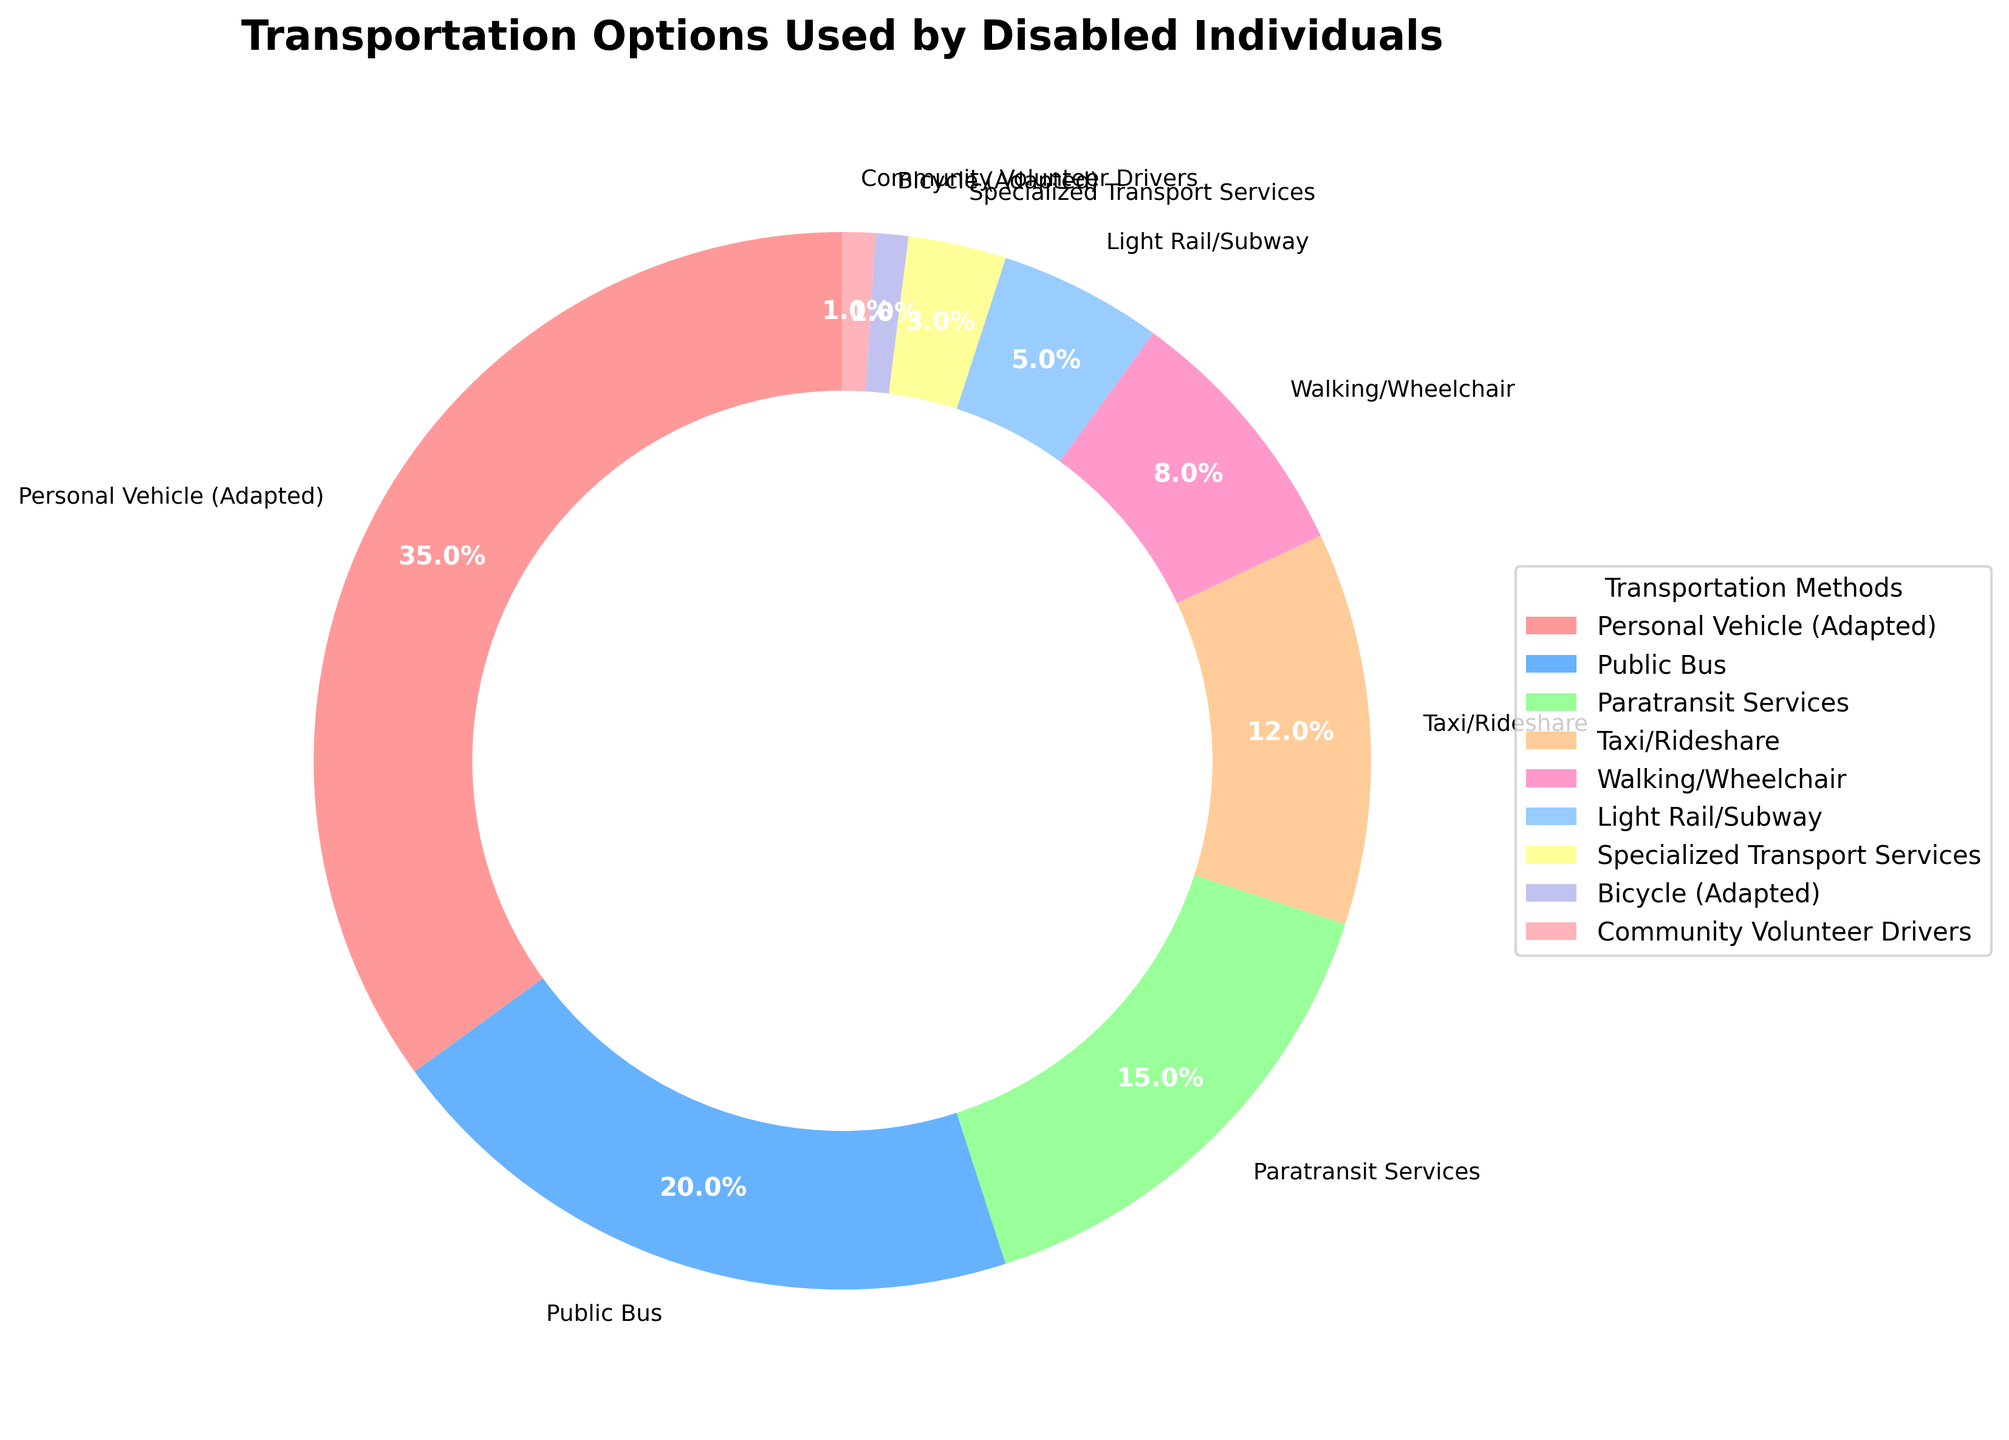Which transportation method is the most commonly used by disabled individuals? The pie chart shows that the largest segment corresponds to "Personal Vehicle (Adapted)" with a percentage of 35%.
Answer: Personal Vehicle (Adapted) Which transportation methods have a smaller percentage than taxi/rideshare? According to the pie chart, the methods with a smaller percentage than "Taxi/Rideshare" (12%) are "Walking/Wheelchair" (8%), "Light Rail/Subway" (5%), "Specialized Transport Services" (3%), "Bicycle (Adapted)" (1%), and "Community Volunteer Drivers" (1%).
Answer: Walking/Wheelchair, Light Rail/Subway, Specialized Transport Services, Bicycle (Adapted), Community Volunteer Drivers What is the combined percentage of Public Bus and Paratransit Services usage? The percentage usage for "Public Bus" is 20% and for "Paratransit Services" is 15%. Adding these together gives 20% + 15% = 35%.
Answer: 35% How does the usage of Paratransit Services compare to Specialized Transport Services? The pie chart indicates that "Paratransit Services" has a usage percentage of 15%, while "Specialized Transport Services" has a percentage of 3%. Comparatively, Paratransit Services are used much more frequently than Specialized Transport Services.
Answer: Paratransit Services is used more What color represents the segment for Community Volunteer Drivers in the pie chart? The segment for "Community Volunteer Drivers" is colored in a light blue hue, distinguished from other colors in the pie chart.
Answer: Light blue What is the difference in usage percentages between the most and least used transportation methods? The most used transportation method is "Personal Vehicle (Adapted)" with 35%, and the least used methods are "Bicycle (Adapted)" and "Community Volunteer Drivers," both with 1%. The difference is 35% - 1% = 34%.
Answer: 34% Which transportation method is used exactly half as much as Taxi/Rideshare? "Taxi/Rideshare" is used by 12%. "Walking/Wheelchair" has a usage percentage of 8%, which is two-thirds and not half. "Light Rail/Subway" is used by 5%, which is nearly half of 12% (12%/2 = 6%). Though not exact, it is the closest match.
Answer: Light Rail/Subway What visual feature is used to highlight the different segments of the pie chart? The pie chart employs various colors to distinguish the segments visually, with each transportation method represented by a distinct color.
Answer: Different colors If the percentages of Taxi/Rideshare and Walking/Wheelchair were combined, would their total be more or less than Public Bus usage? Taxi/Rideshare is 12% and Walking/Wheelchair is 8%. Their combined total is 12% + 8% = 20%, which is the same as the Public Bus usage of 20%.
Answer: The same What is the sum of percentages for all methods with less than 10% usage? The methods with less than 10% usage are "Walking/Wheelchair" (8%), "Light Rail/Subway" (5%), "Specialized Transport Services" (3%), "Bicycle (Adapted)" (1%), and "Community Volunteer Drivers" (1%). Adding these together gives 8% + 5% + 3% + 1% + 1% = 18%.
Answer: 18% 